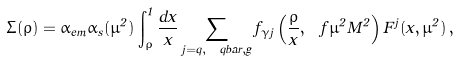Convert formula to latex. <formula><loc_0><loc_0><loc_500><loc_500>\Sigma ( \rho ) = \alpha _ { e m } \alpha _ { s } ( \mu ^ { 2 } ) \int _ { \rho } ^ { 1 } \frac { d x } { x } \sum _ { j = q , \ q b a r , g } f _ { \gamma j } \left ( \frac { \rho } { x } , \ f { \mu ^ { 2 } } { M ^ { 2 } } \right ) F ^ { j } ( x , \mu ^ { 2 } ) \, ,</formula> 